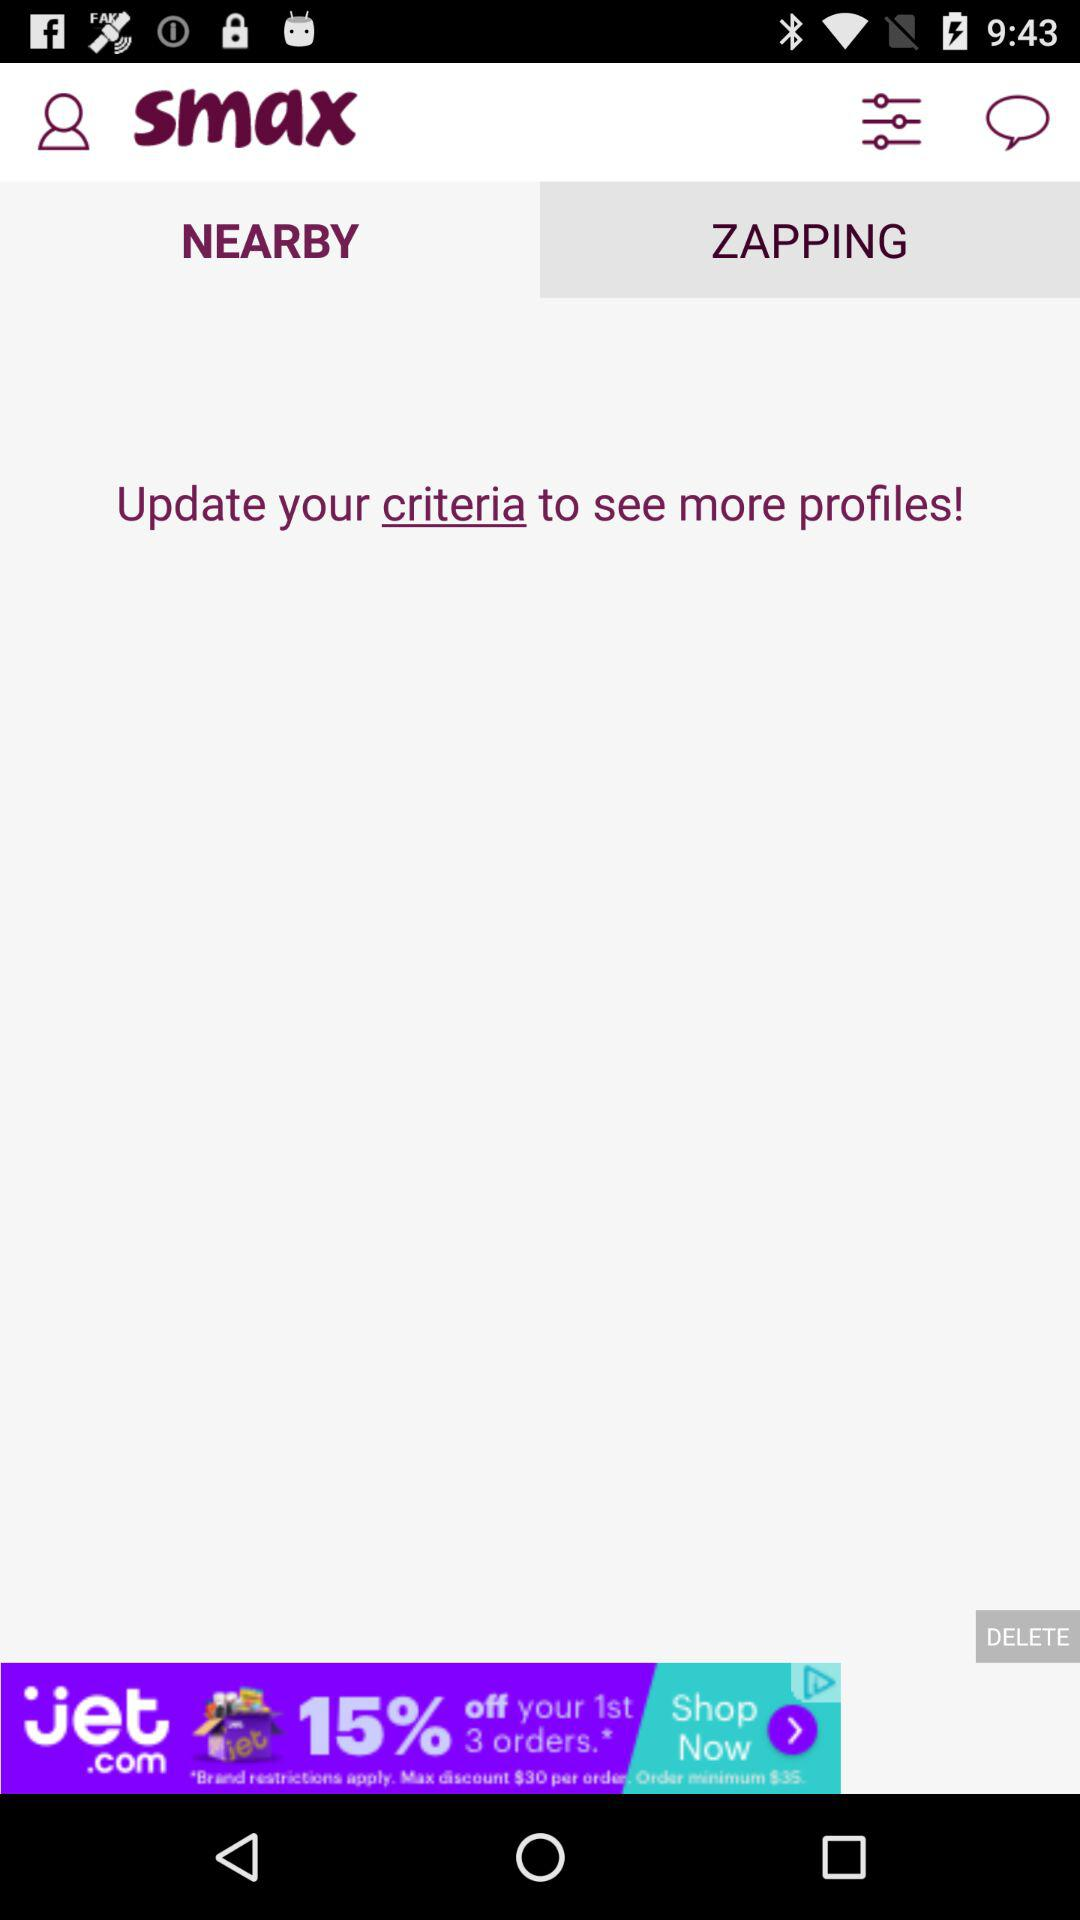Which tab is currently selected? The selected tab is "NEARBY". 